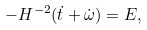Convert formula to latex. <formula><loc_0><loc_0><loc_500><loc_500>- H ^ { - 2 } ( \dot { t } + \dot { \omega } ) = E ,</formula> 